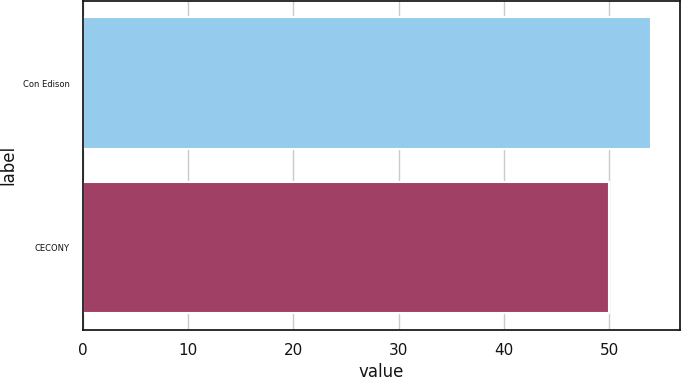<chart> <loc_0><loc_0><loc_500><loc_500><bar_chart><fcel>Con Edison<fcel>CECONY<nl><fcel>54<fcel>50<nl></chart> 